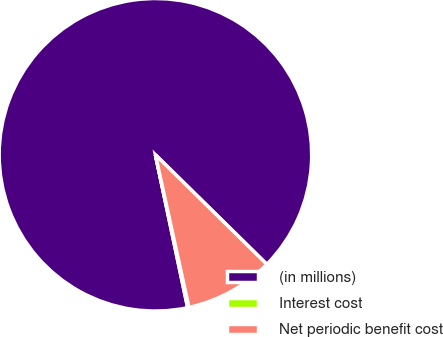<chart> <loc_0><loc_0><loc_500><loc_500><pie_chart><fcel>(in millions)<fcel>Interest cost<fcel>Net periodic benefit cost<nl><fcel>90.68%<fcel>0.14%<fcel>9.19%<nl></chart> 